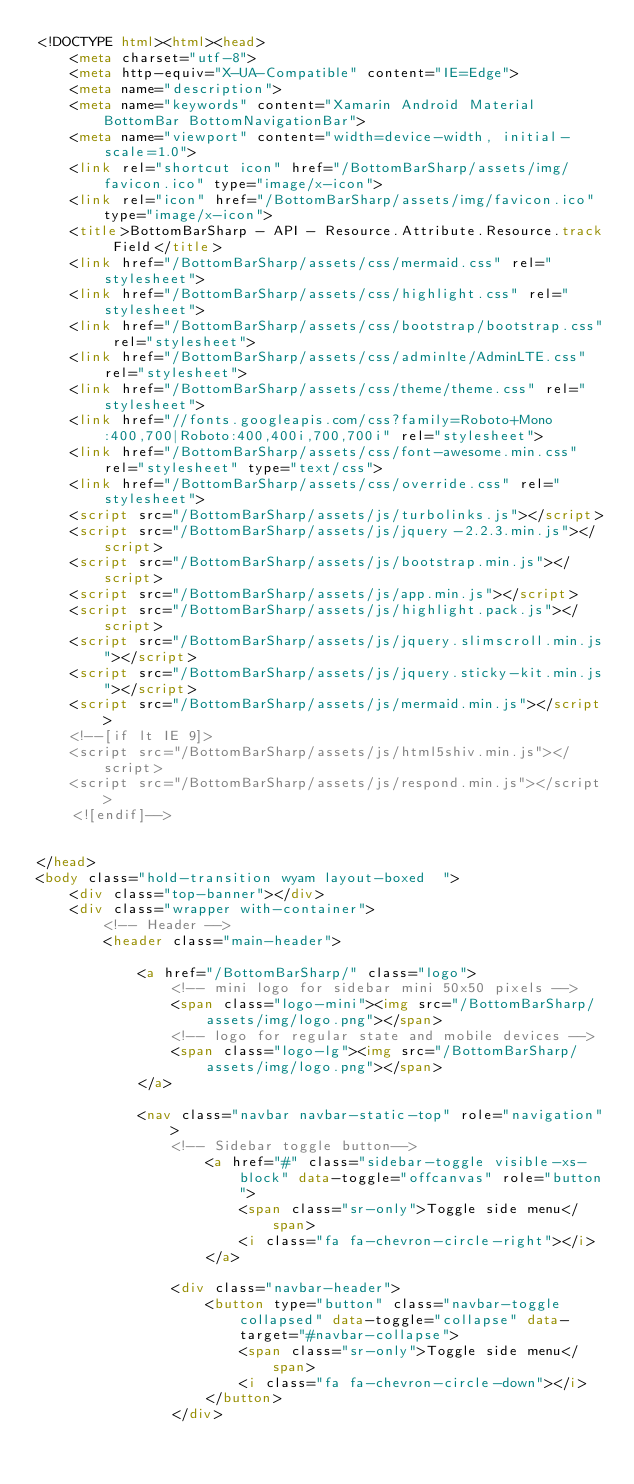<code> <loc_0><loc_0><loc_500><loc_500><_HTML_><!DOCTYPE html><html><head>
    <meta charset="utf-8">
    <meta http-equiv="X-UA-Compatible" content="IE=Edge">
    <meta name="description">
    <meta name="keywords" content="Xamarin Android Material BottomBar BottomNavigationBar">
    <meta name="viewport" content="width=device-width, initial-scale=1.0">
    <link rel="shortcut icon" href="/BottomBarSharp/assets/img/favicon.ico" type="image/x-icon">
    <link rel="icon" href="/BottomBarSharp/assets/img/favicon.ico" type="image/x-icon">
    <title>BottomBarSharp - API - Resource.Attribute.Resource.track Field</title>
    <link href="/BottomBarSharp/assets/css/mermaid.css" rel="stylesheet">
    <link href="/BottomBarSharp/assets/css/highlight.css" rel="stylesheet">
    <link href="/BottomBarSharp/assets/css/bootstrap/bootstrap.css" rel="stylesheet">
    <link href="/BottomBarSharp/assets/css/adminlte/AdminLTE.css" rel="stylesheet">
    <link href="/BottomBarSharp/assets/css/theme/theme.css" rel="stylesheet">
    <link href="//fonts.googleapis.com/css?family=Roboto+Mono:400,700|Roboto:400,400i,700,700i" rel="stylesheet">
    <link href="/BottomBarSharp/assets/css/font-awesome.min.css" rel="stylesheet" type="text/css">
    <link href="/BottomBarSharp/assets/css/override.css" rel="stylesheet">
    <script src="/BottomBarSharp/assets/js/turbolinks.js"></script>
    <script src="/BottomBarSharp/assets/js/jquery-2.2.3.min.js"></script>
    <script src="/BottomBarSharp/assets/js/bootstrap.min.js"></script>
    <script src="/BottomBarSharp/assets/js/app.min.js"></script>
    <script src="/BottomBarSharp/assets/js/highlight.pack.js"></script>
    <script src="/BottomBarSharp/assets/js/jquery.slimscroll.min.js"></script>
    <script src="/BottomBarSharp/assets/js/jquery.sticky-kit.min.js"></script>
    <script src="/BottomBarSharp/assets/js/mermaid.min.js"></script>
    <!--[if lt IE 9]>
    <script src="/BottomBarSharp/assets/js/html5shiv.min.js"></script>
    <script src="/BottomBarSharp/assets/js/respond.min.js"></script>
    <![endif]-->

    
</head>
<body class="hold-transition wyam layout-boxed  ">
    <div class="top-banner"></div>
    <div class="wrapper with-container">
        <!-- Header -->
        <header class="main-header">

            <a href="/BottomBarSharp/" class="logo">
                <!-- mini logo for sidebar mini 50x50 pixels -->
                <span class="logo-mini"><img src="/BottomBarSharp/assets/img/logo.png"></span>
                <!-- logo for regular state and mobile devices -->
                <span class="logo-lg"><img src="/BottomBarSharp/assets/img/logo.png"></span>
            </a>

            <nav class="navbar navbar-static-top" role="navigation">
                <!-- Sidebar toggle button-->
                    <a href="#" class="sidebar-toggle visible-xs-block" data-toggle="offcanvas" role="button">
                        <span class="sr-only">Toggle side menu</span>
                        <i class="fa fa-chevron-circle-right"></i>
                    </a>

                <div class="navbar-header">
                    <button type="button" class="navbar-toggle collapsed" data-toggle="collapse" data-target="#navbar-collapse">
                        <span class="sr-only">Toggle side menu</span>
                        <i class="fa fa-chevron-circle-down"></i>
                    </button>
                </div>
</code> 